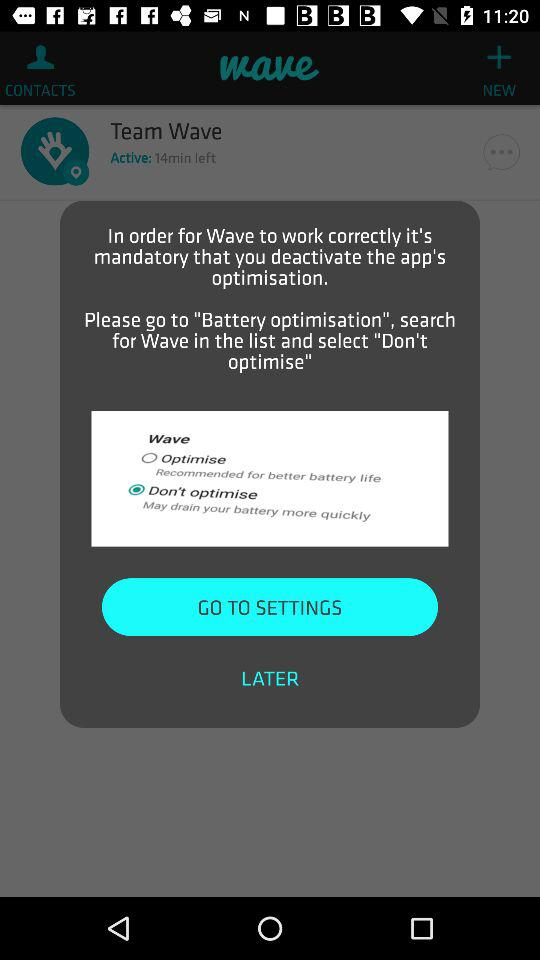What is the application name? The application name is "wave". 